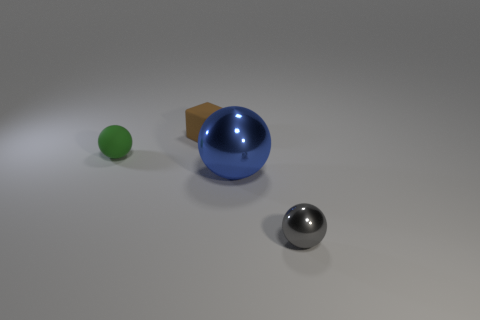Add 4 tiny metal objects. How many objects exist? 8 Subtract all blocks. How many objects are left? 3 Subtract all small yellow matte blocks. Subtract all large metallic things. How many objects are left? 3 Add 4 small brown blocks. How many small brown blocks are left? 5 Add 1 red metal spheres. How many red metal spheres exist? 1 Subtract 0 cyan blocks. How many objects are left? 4 